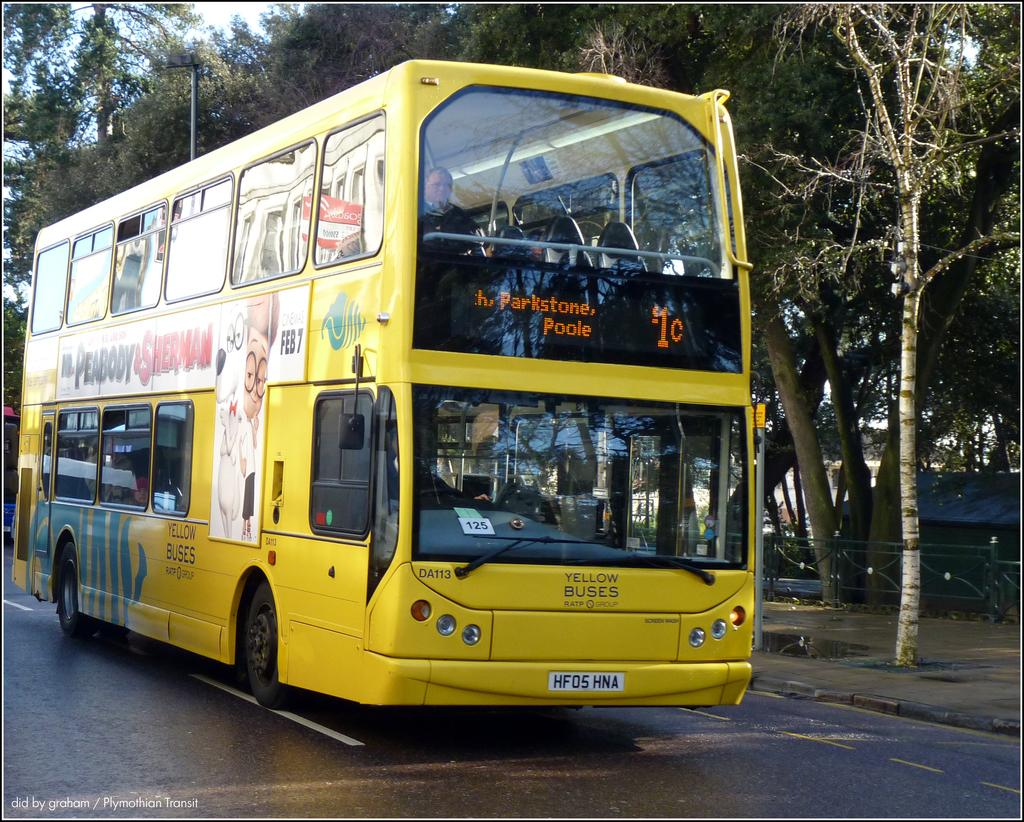What is the main subject of the image? There is a bus on the road in the image. What can be seen in the background of the image? There are trees and the sky visible in the background of the image. Are there any structures or objects in the image besides the bus? Yes, there is a pole and a railing in the image. Can you see a volcano erupting in the background of the image? No, there is no volcano present in the image. What type of cast is visible on the bus driver's arm in the image? There is no cast visible on anyone's arm in the image. 